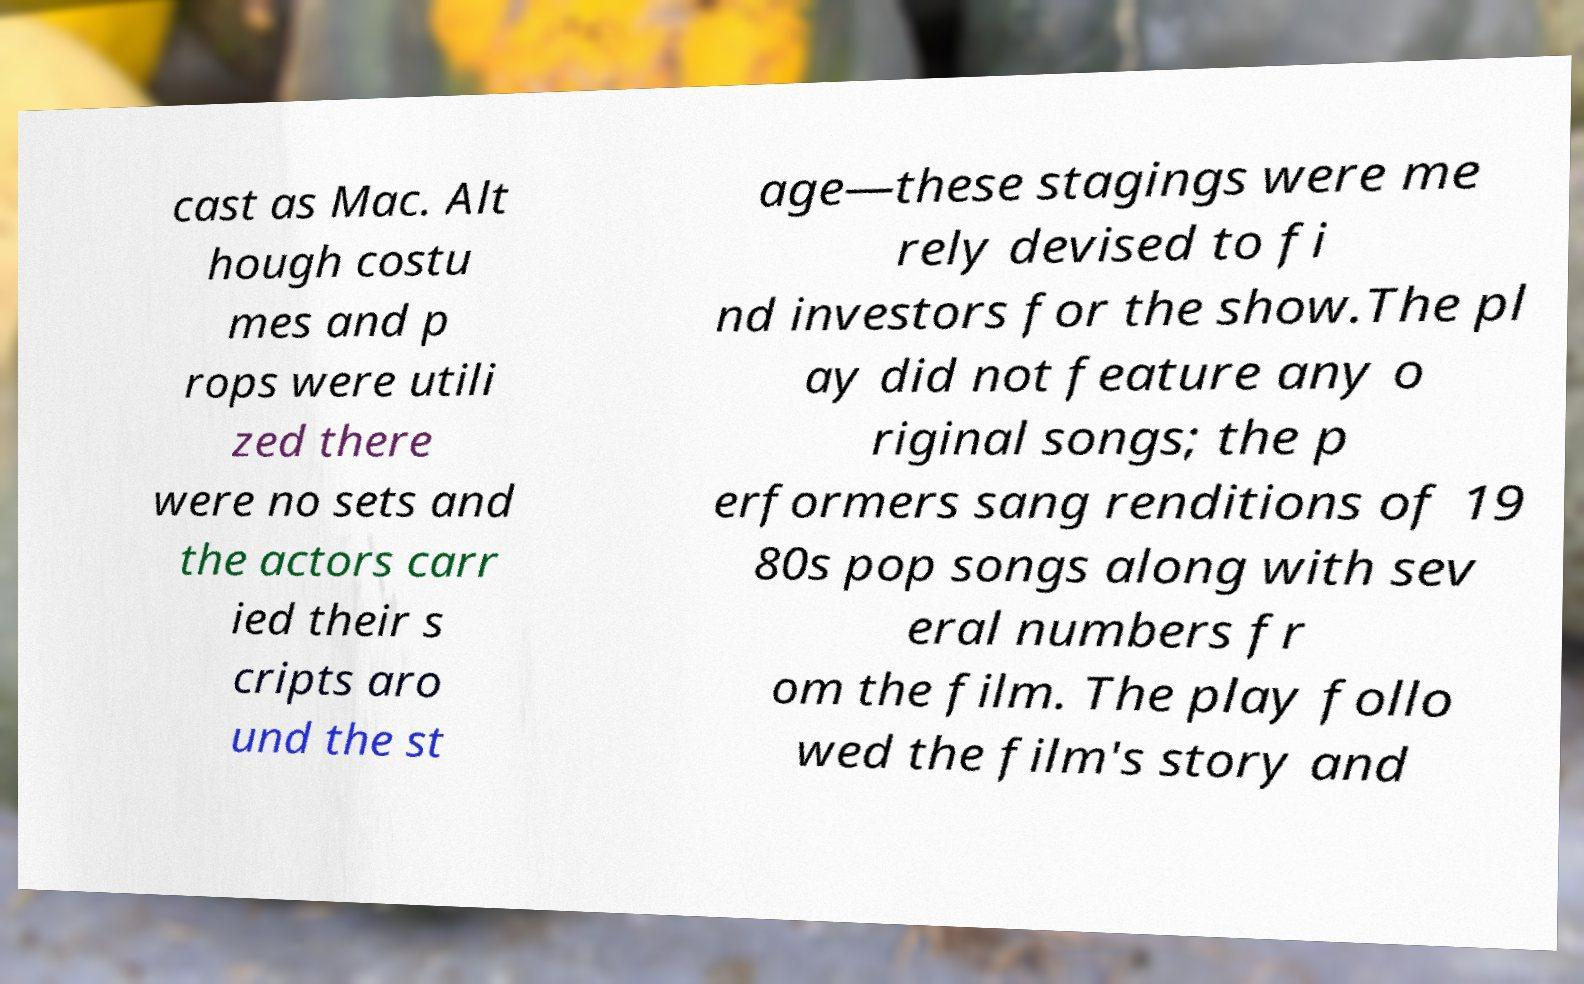For documentation purposes, I need the text within this image transcribed. Could you provide that? cast as Mac. Alt hough costu mes and p rops were utili zed there were no sets and the actors carr ied their s cripts aro und the st age—these stagings were me rely devised to fi nd investors for the show.The pl ay did not feature any o riginal songs; the p erformers sang renditions of 19 80s pop songs along with sev eral numbers fr om the film. The play follo wed the film's story and 